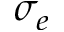<formula> <loc_0><loc_0><loc_500><loc_500>\sigma _ { e }</formula> 